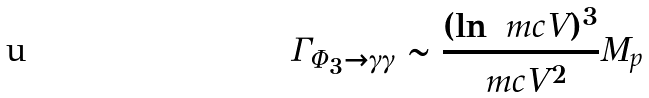<formula> <loc_0><loc_0><loc_500><loc_500>\Gamma _ { \Phi _ { 3 } \rightarrow \gamma \gamma } \sim \frac { ( \ln \ m c { V } ) ^ { 3 } } { \ m c { V } ^ { 2 } } M _ { p }</formula> 